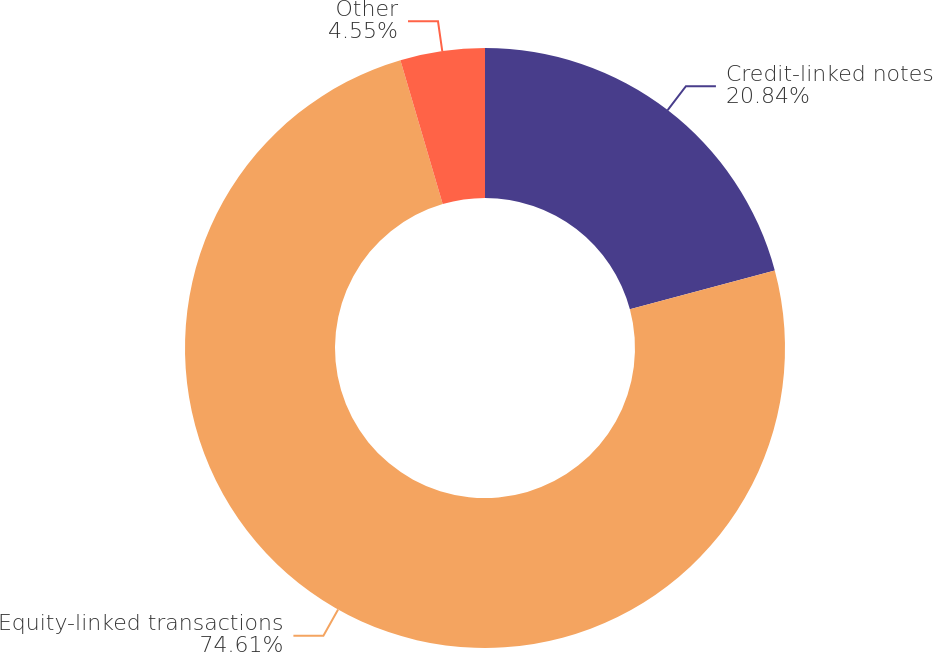Convert chart. <chart><loc_0><loc_0><loc_500><loc_500><pie_chart><fcel>Credit-linked notes<fcel>Equity-linked transactions<fcel>Other<nl><fcel>20.84%<fcel>74.62%<fcel>4.55%<nl></chart> 